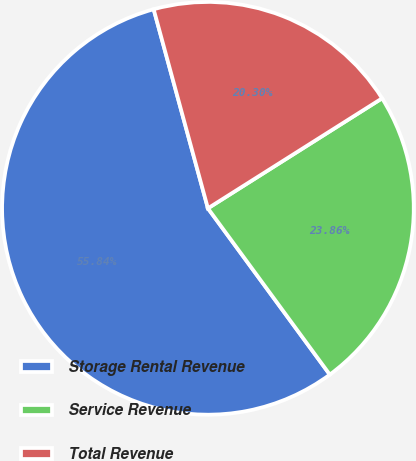<chart> <loc_0><loc_0><loc_500><loc_500><pie_chart><fcel>Storage Rental Revenue<fcel>Service Revenue<fcel>Total Revenue<nl><fcel>55.84%<fcel>23.86%<fcel>20.3%<nl></chart> 